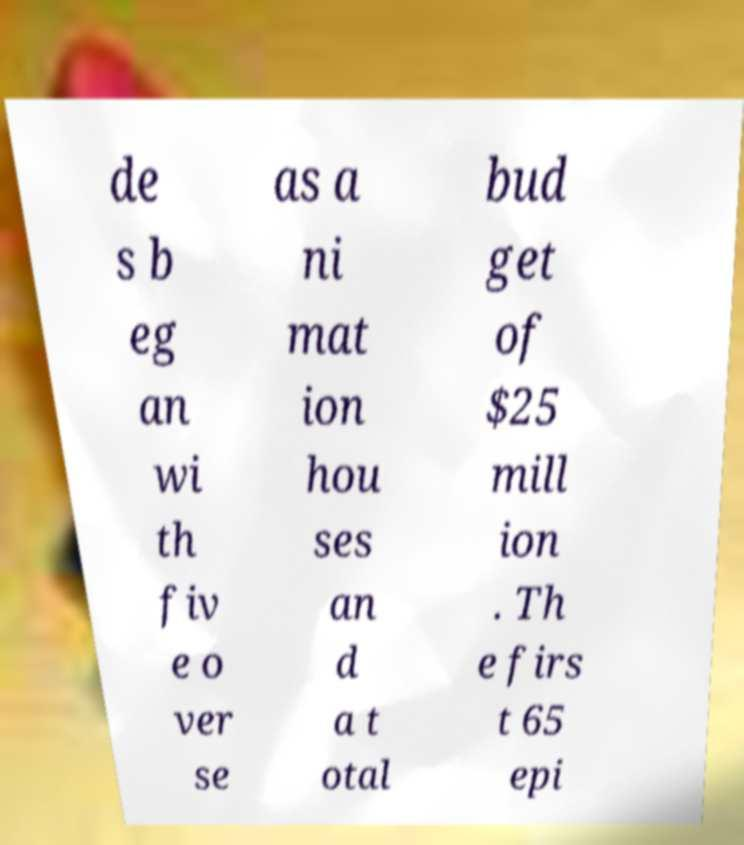Can you accurately transcribe the text from the provided image for me? de s b eg an wi th fiv e o ver se as a ni mat ion hou ses an d a t otal bud get of $25 mill ion . Th e firs t 65 epi 